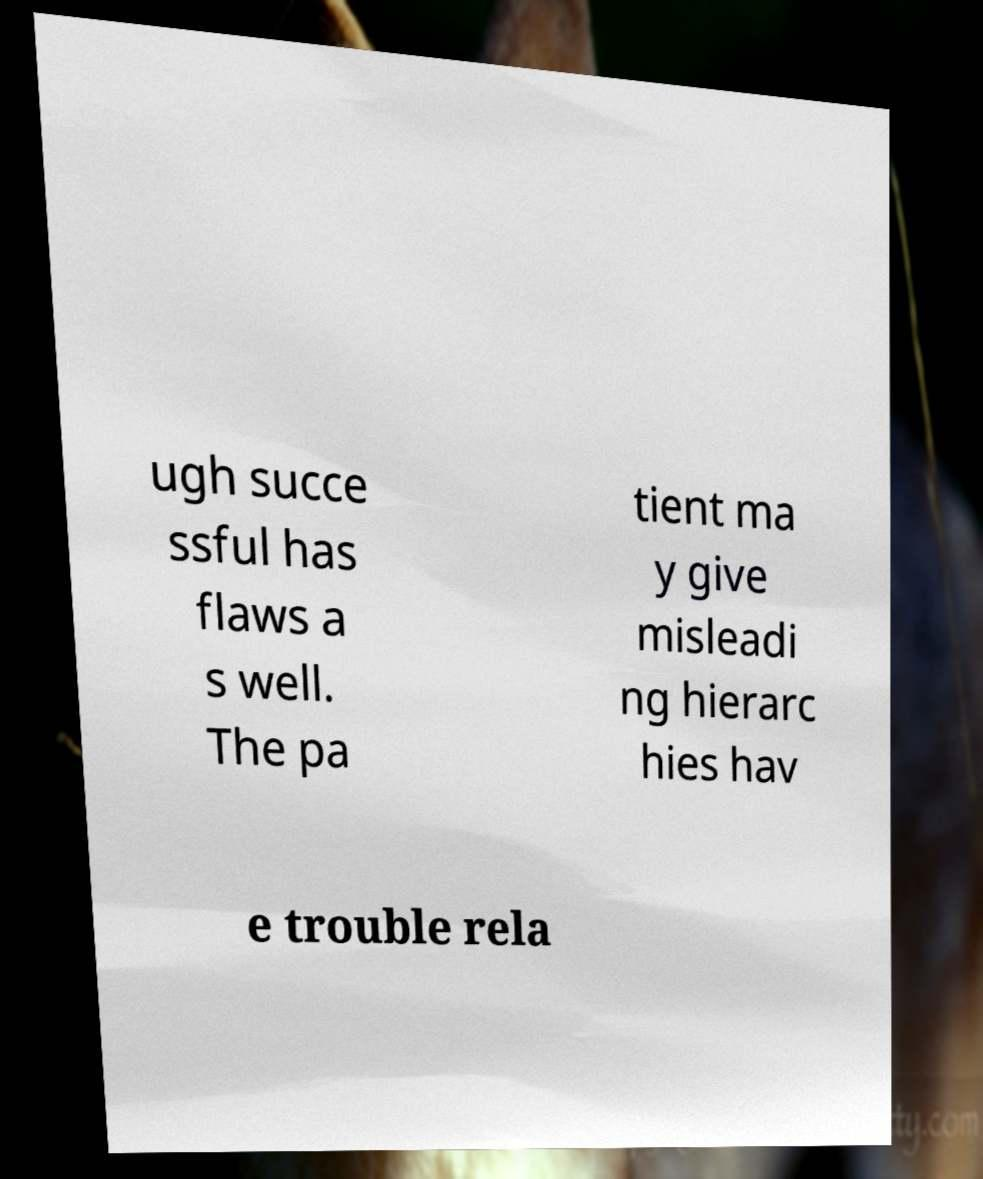Can you read and provide the text displayed in the image?This photo seems to have some interesting text. Can you extract and type it out for me? ugh succe ssful has flaws a s well. The pa tient ma y give misleadi ng hierarc hies hav e trouble rela 